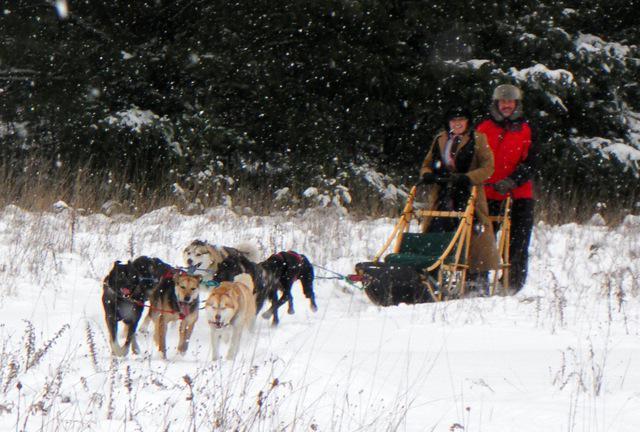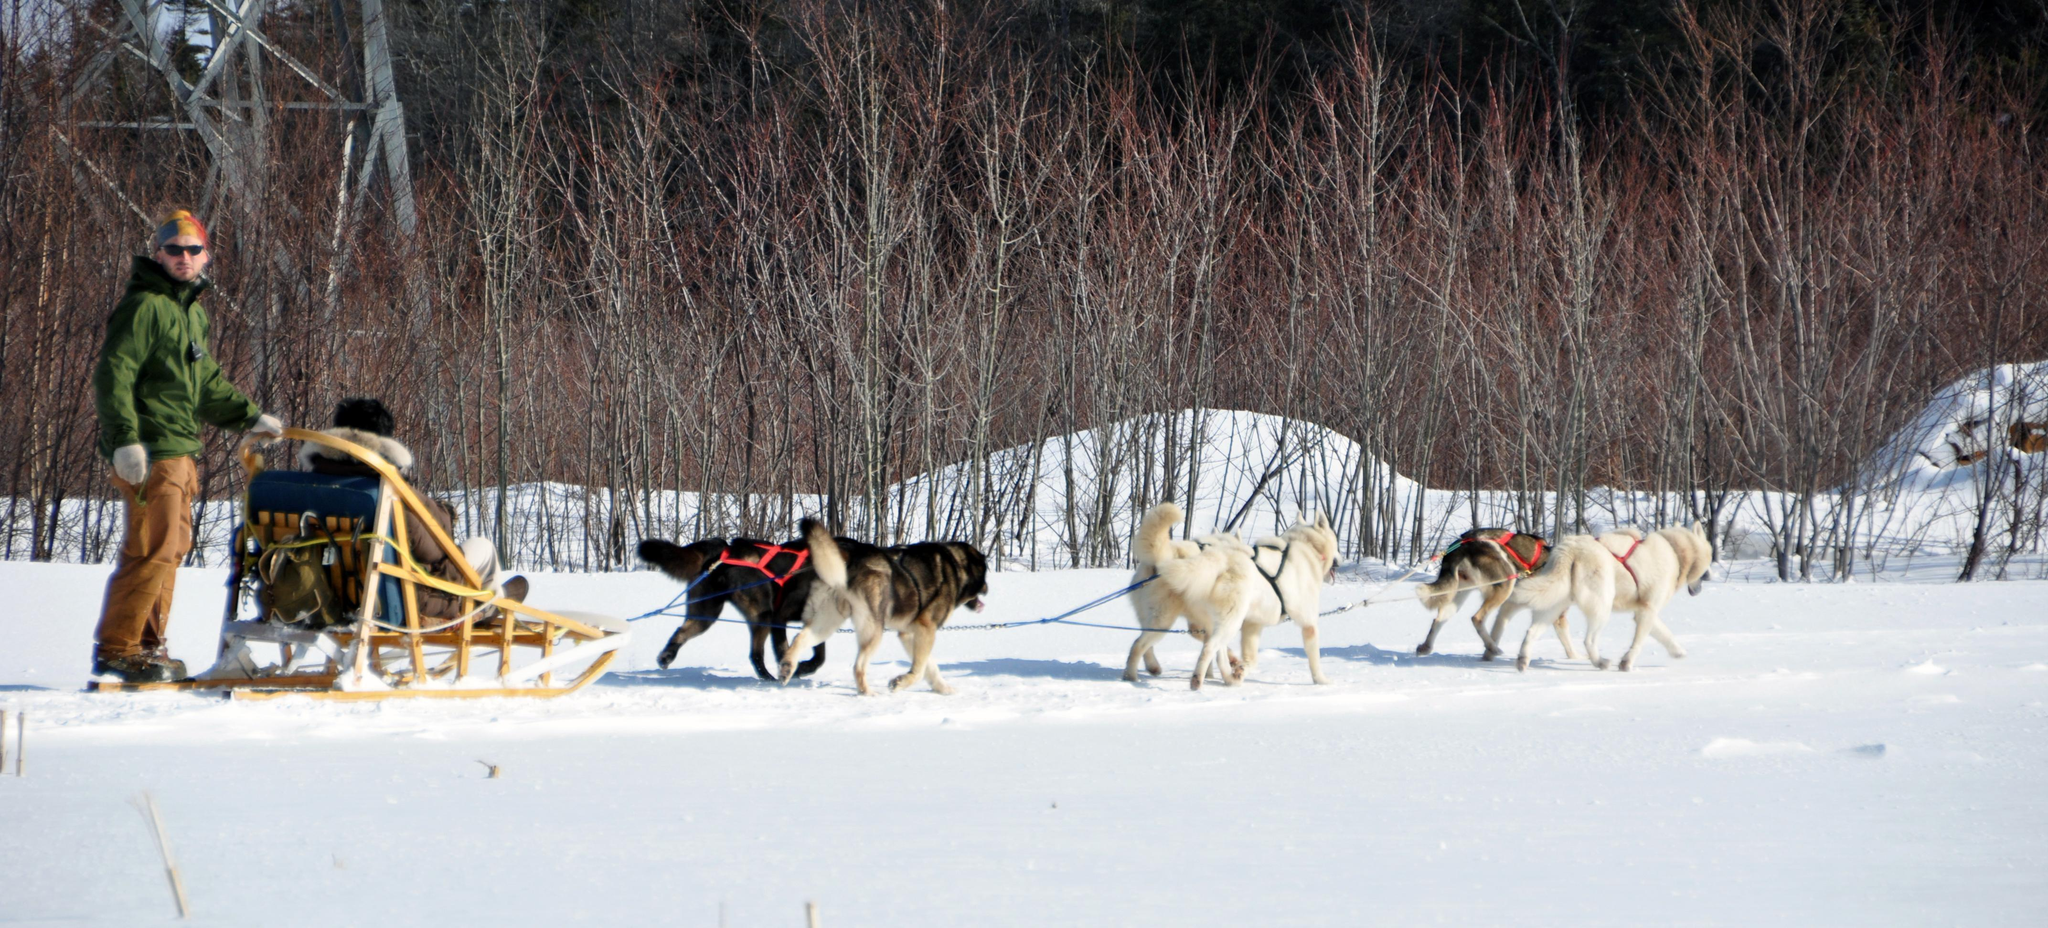The first image is the image on the left, the second image is the image on the right. Given the left and right images, does the statement "One dog is sitting." hold true? Answer yes or no. No. The first image is the image on the left, the second image is the image on the right. Examine the images to the left and right. Is the description "The dog sled teams in the left and right images appear to be heading toward each other." accurate? Answer yes or no. No. 